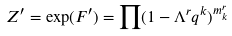Convert formula to latex. <formula><loc_0><loc_0><loc_500><loc_500>Z ^ { \prime } = \exp ( F ^ { \prime } ) = \prod ( 1 - \Lambda ^ { r } q ^ { k } ) ^ { m ^ { r } _ { k } }</formula> 